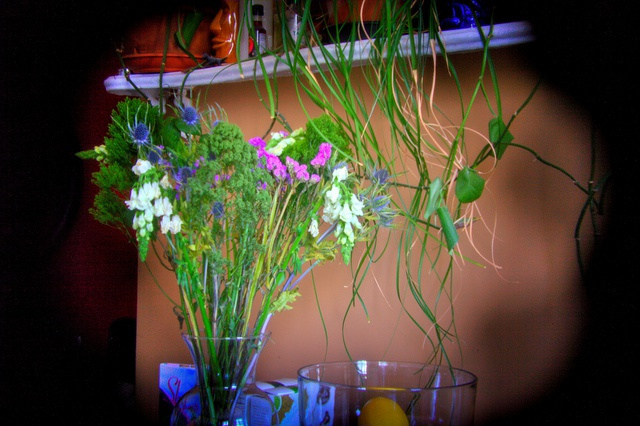Describe the objects in this image and their specific colors. I can see potted plant in black, salmon, olive, and darkgreen tones, cup in black, brown, maroon, and olive tones, vase in black, brown, maroon, and olive tones, and vase in black, gray, darkgreen, and navy tones in this image. 